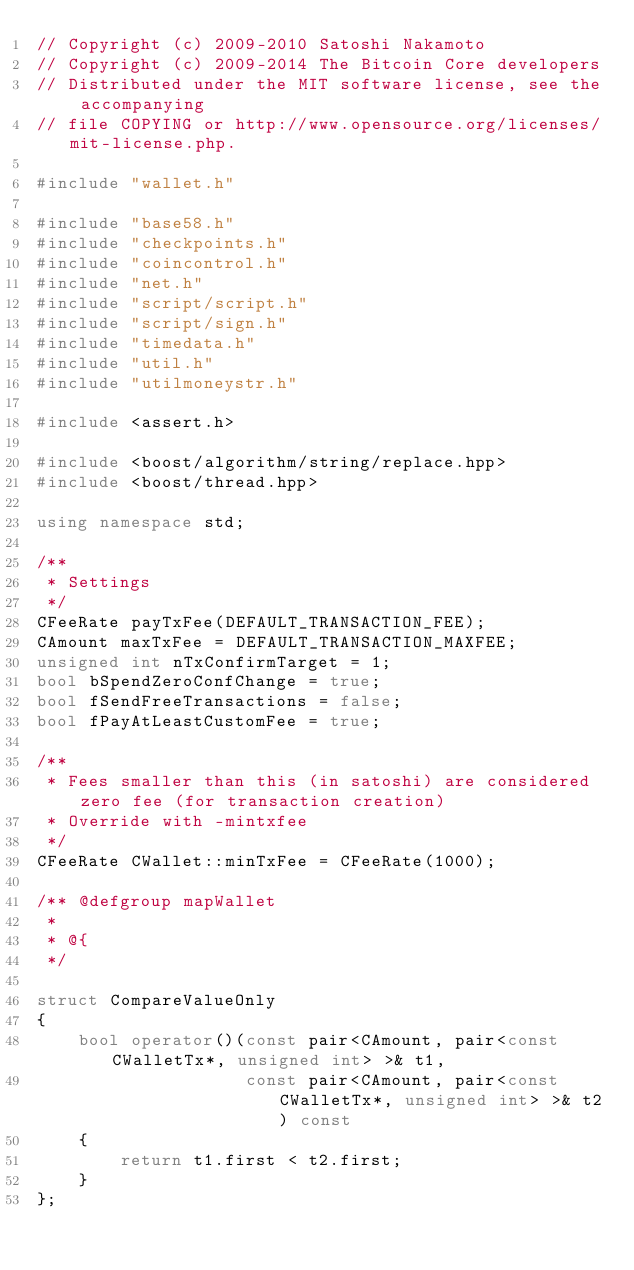<code> <loc_0><loc_0><loc_500><loc_500><_C++_>// Copyright (c) 2009-2010 Satoshi Nakamoto
// Copyright (c) 2009-2014 The Bitcoin Core developers
// Distributed under the MIT software license, see the accompanying
// file COPYING or http://www.opensource.org/licenses/mit-license.php.

#include "wallet.h"

#include "base58.h"
#include "checkpoints.h"
#include "coincontrol.h"
#include "net.h"
#include "script/script.h"
#include "script/sign.h"
#include "timedata.h"
#include "util.h"
#include "utilmoneystr.h"

#include <assert.h>

#include <boost/algorithm/string/replace.hpp>
#include <boost/thread.hpp>

using namespace std;

/**
 * Settings
 */
CFeeRate payTxFee(DEFAULT_TRANSACTION_FEE);
CAmount maxTxFee = DEFAULT_TRANSACTION_MAXFEE;
unsigned int nTxConfirmTarget = 1;
bool bSpendZeroConfChange = true;
bool fSendFreeTransactions = false;
bool fPayAtLeastCustomFee = true;

/** 
 * Fees smaller than this (in satoshi) are considered zero fee (for transaction creation) 
 * Override with -mintxfee
 */
CFeeRate CWallet::minTxFee = CFeeRate(1000);

/** @defgroup mapWallet
 *
 * @{
 */

struct CompareValueOnly
{
    bool operator()(const pair<CAmount, pair<const CWalletTx*, unsigned int> >& t1,
                    const pair<CAmount, pair<const CWalletTx*, unsigned int> >& t2) const
    {
        return t1.first < t2.first;
    }
};
</code> 